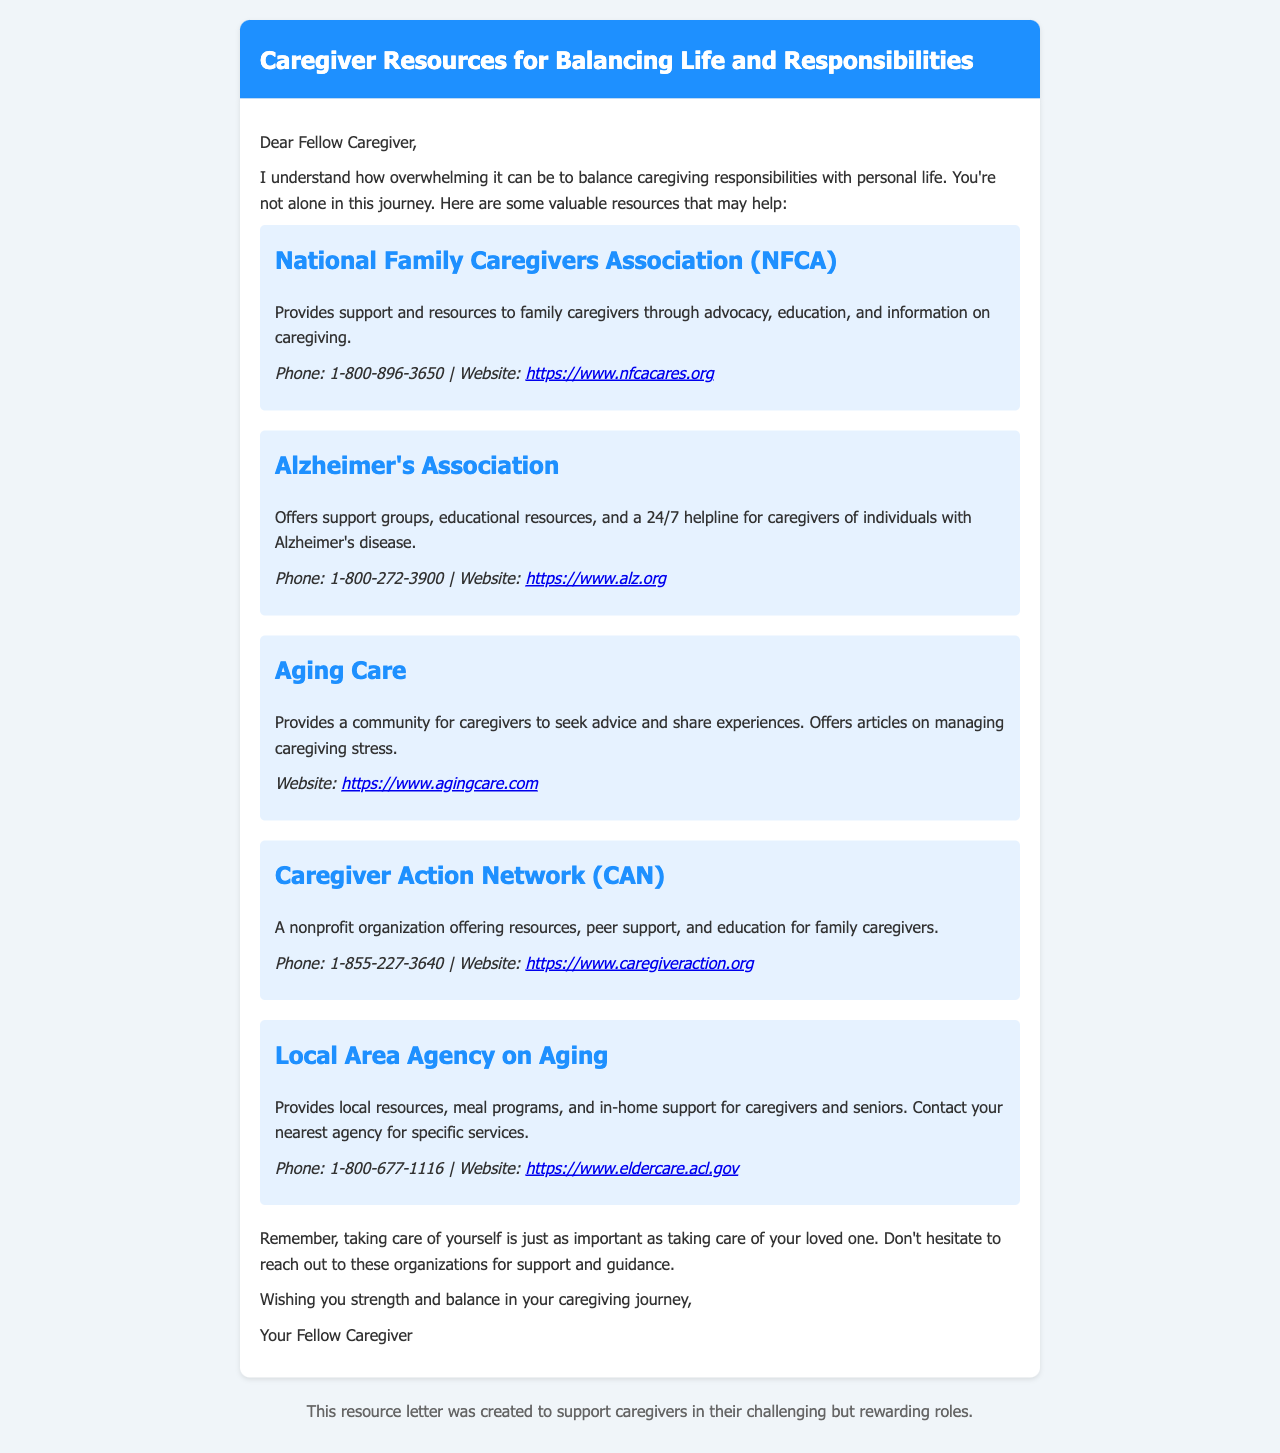what is the phone number for the National Family Caregivers Association? The phone number is provided in the resource section for the National Family Caregivers Association.
Answer: 1-800-896-3650 what type of support does the Alzheimer's Association provide? The types of support offered are outlined in the description for the Alzheimer's Association.
Answer: Support groups, educational resources, and a 24/7 helpline what is the website for Aging Care? The website is listed in the resource section for Aging Care.
Answer: https://www.agingcare.com how can caregivers benefit from the Caregiver Action Network? The benefits are found in the description of the Caregiver Action Network within the document.
Answer: Resources, peer support, and education which organization offers meal programs and in-home support? The organization providing these services can be found in the section for the Local Area Agency on Aging.
Answer: Local Area Agency on Aging what is the main purpose of this document? The main purpose of the document is specified at the beginning of the letter.
Answer: To support caregivers in their challenging but rewarding roles which organization provides a 24/7 helpline? The organization that offers a 24/7 helpline is mentioned in relation to the services they provide.
Answer: Alzheimer's Association what color is the header of the document? The color is described in the styling section for the header.
Answer: Blue 